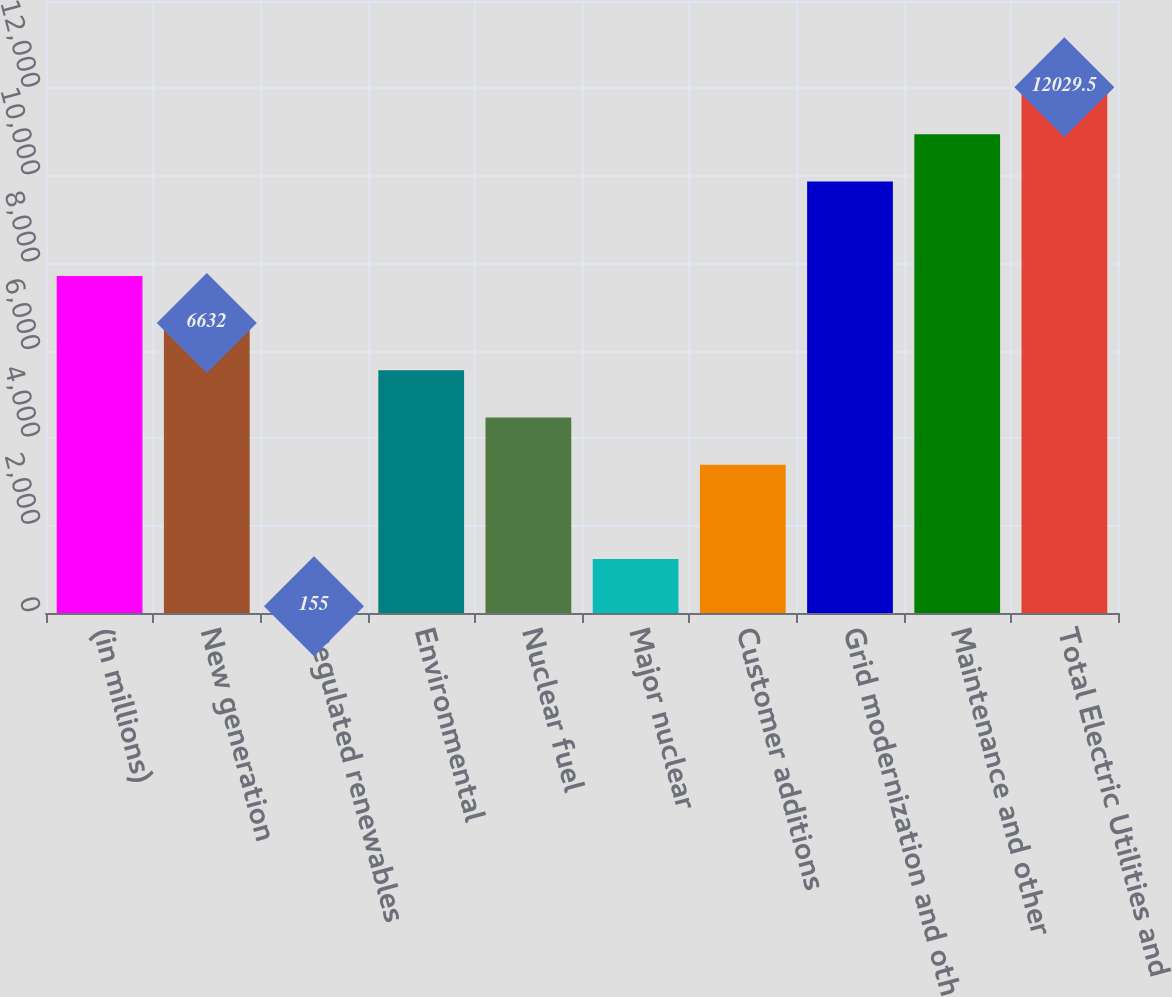<chart> <loc_0><loc_0><loc_500><loc_500><bar_chart><fcel>(in millions)<fcel>New generation<fcel>Regulated renewables<fcel>Environmental<fcel>Nuclear fuel<fcel>Major nuclear<fcel>Customer additions<fcel>Grid modernization and other<fcel>Maintenance and other<fcel>Total Electric Utilities and<nl><fcel>7711.5<fcel>6632<fcel>155<fcel>5552.5<fcel>4473<fcel>1234.5<fcel>3393.5<fcel>9870.5<fcel>10950<fcel>12029.5<nl></chart> 